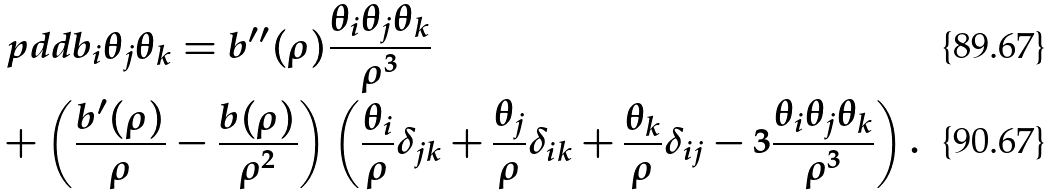<formula> <loc_0><loc_0><loc_500><loc_500>& \ p d d { b _ { i } } { \theta _ { j } } { \theta _ { k } } = b ^ { \prime \prime } ( \rho ) \frac { \theta _ { i } \theta _ { j } \theta _ { k } } { \rho ^ { 3 } } \\ & + \left ( \frac { b ^ { \prime } ( \rho ) } { \rho } - \frac { b ( \rho ) } { \rho ^ { 2 } } \right ) \left ( \frac { \theta _ { i } } { \rho } \delta _ { j k } + \frac { \theta _ { j } } { \rho } \delta _ { i k } + \frac { \theta _ { k } } { \rho } \delta _ { i j } - 3 \frac { \theta _ { i } \theta _ { j } \theta _ { k } } { \rho ^ { 3 } } \right ) .</formula> 